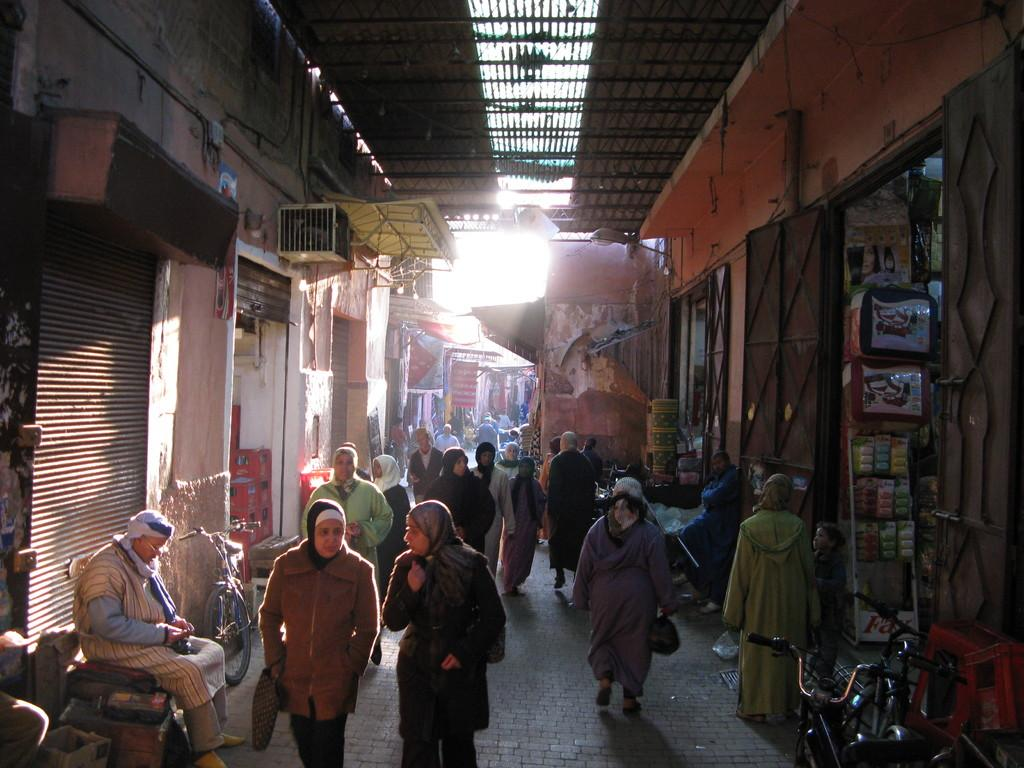What is the main feature of the image? There is a path or way in the image. What are the people in the image doing? There are people walking on the path. What type of establishments can be seen alongside the path? There are shops on either side of the path. What color is the bear's umbrella in the image? There is no bear or umbrella present in the image. 